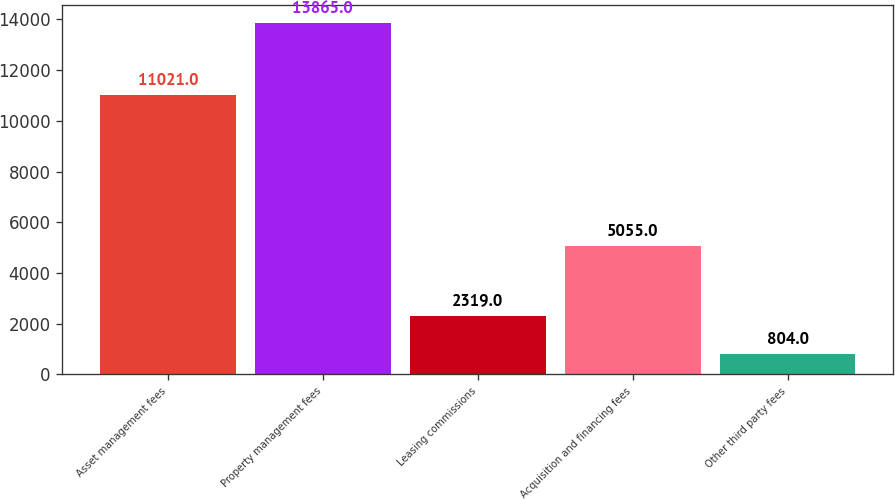Convert chart to OTSL. <chart><loc_0><loc_0><loc_500><loc_500><bar_chart><fcel>Asset management fees<fcel>Property management fees<fcel>Leasing commissions<fcel>Acquisition and financing fees<fcel>Other third party fees<nl><fcel>11021<fcel>13865<fcel>2319<fcel>5055<fcel>804<nl></chart> 